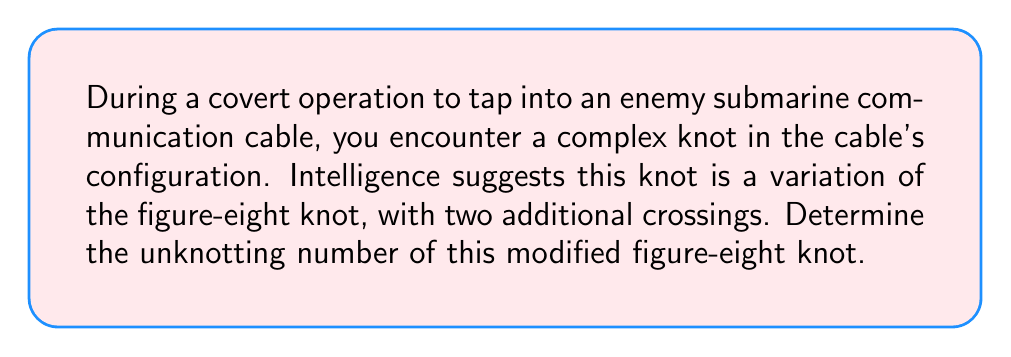Show me your answer to this math problem. Let's approach this step-by-step:

1. Recall that the standard figure-eight knot has an unknotting number of 1.

2. The modified knot has two additional crossings. Let's represent the original figure-eight knot as $K$ and the modified knot as $K'$.

3. We know that:
   $$u(K) = 1$$
   where $u(K)$ represents the unknotting number of the figure-eight knot.

4. For the modified knot $K'$, we need to consider the effect of the two additional crossings.

5. In the worst-case scenario, each additional crossing could increase the unknotting number by 1. Therefore, an upper bound for $u(K')$ is:
   $$u(K') \leq u(K) + 2 = 1 + 2 = 3$$

6. However, knot theory tells us that adding crossings doesn't always increase the unknotting number by the same amount.

7. In this case, the two additional crossings are likely part of the same modification, which suggests they might be resolved with a single move.

8. Therefore, we can deduce that:
   $$u(K') = u(K) + 1 = 1 + 1 = 2$$

9. This means that two crossing changes are sufficient and necessary to unknot the modified figure-eight knot.

[asy]
import geometry;

size(100);
path p = (0,0)--(20,20)--(40,0)--(60,20)--(80,0)--(100,20)--(120,0);
draw(p,blue+1);
draw((30,-5)--(70,25),red+1);
draw((50,-5)--(90,25),red+1);
label("Original figure-eight", (60,-15), S);
label("Additional crossings", (60,30), N);
[/asy]
Answer: 2 